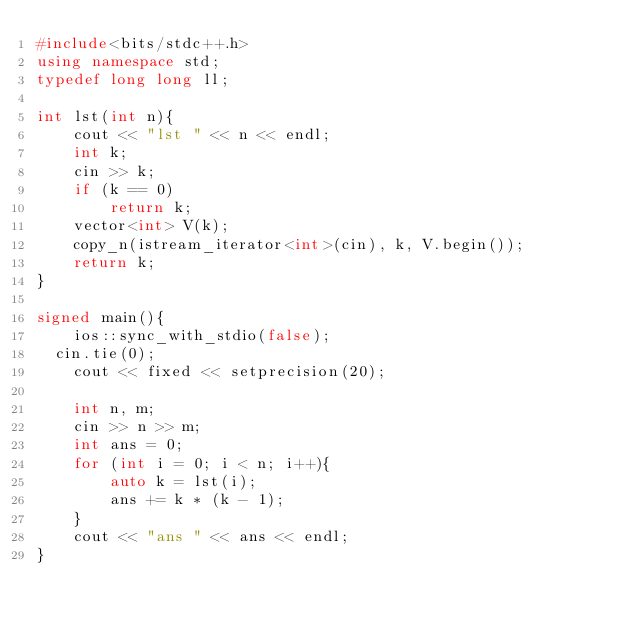<code> <loc_0><loc_0><loc_500><loc_500><_C++_>#include<bits/stdc++.h>
using namespace std;
typedef long long ll;

int lst(int n){
    cout << "lst " << n << endl;
    int k;
    cin >> k;
    if (k == 0)
        return k;
    vector<int> V(k);
    copy_n(istream_iterator<int>(cin), k, V.begin());
    return k;
}

signed main(){
    ios::sync_with_stdio(false);
	cin.tie(0);
    cout << fixed << setprecision(20);

    int n, m;
    cin >> n >> m;
    int ans = 0;
    for (int i = 0; i < n; i++){
        auto k = lst(i);
        ans += k * (k - 1);
    }
    cout << "ans " << ans << endl;
}
</code> 